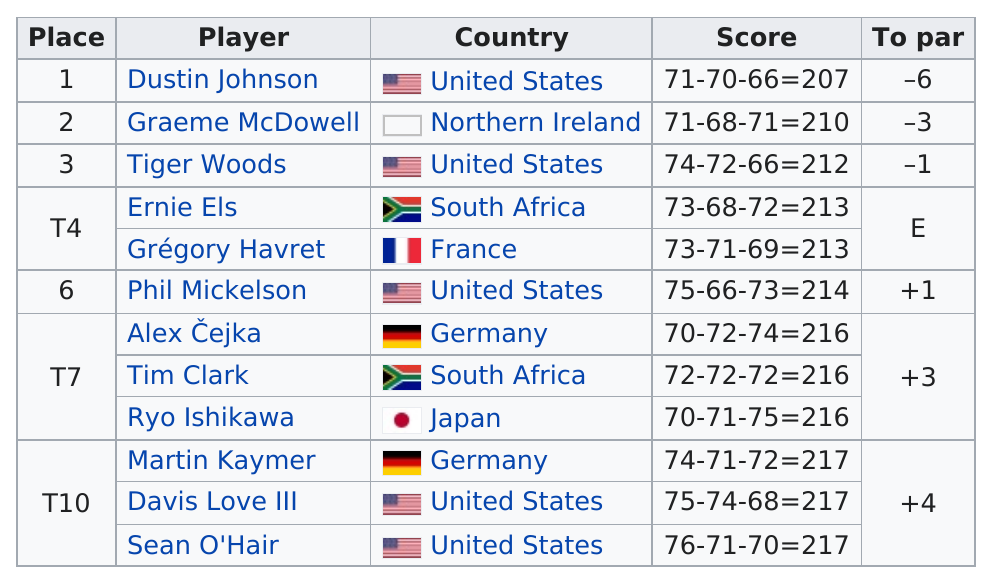Identify some key points in this picture. Only Tim Clark and Alex Cejka, along with Ryo Ishikawa, shot a 3-over-par score at the 2010 US Open. Phil Mickelson had a lower score than Time Clark. The total number of players who tied for fourth, seventh, and tenth place is 8. At the 2010 US Open, a significant number of golfers were able to shoot at least 2 under par. In particular, there were at least 2 golfers who achieved this feat. Of the golfers participating in the third round, a total of 5 are from the United States. 